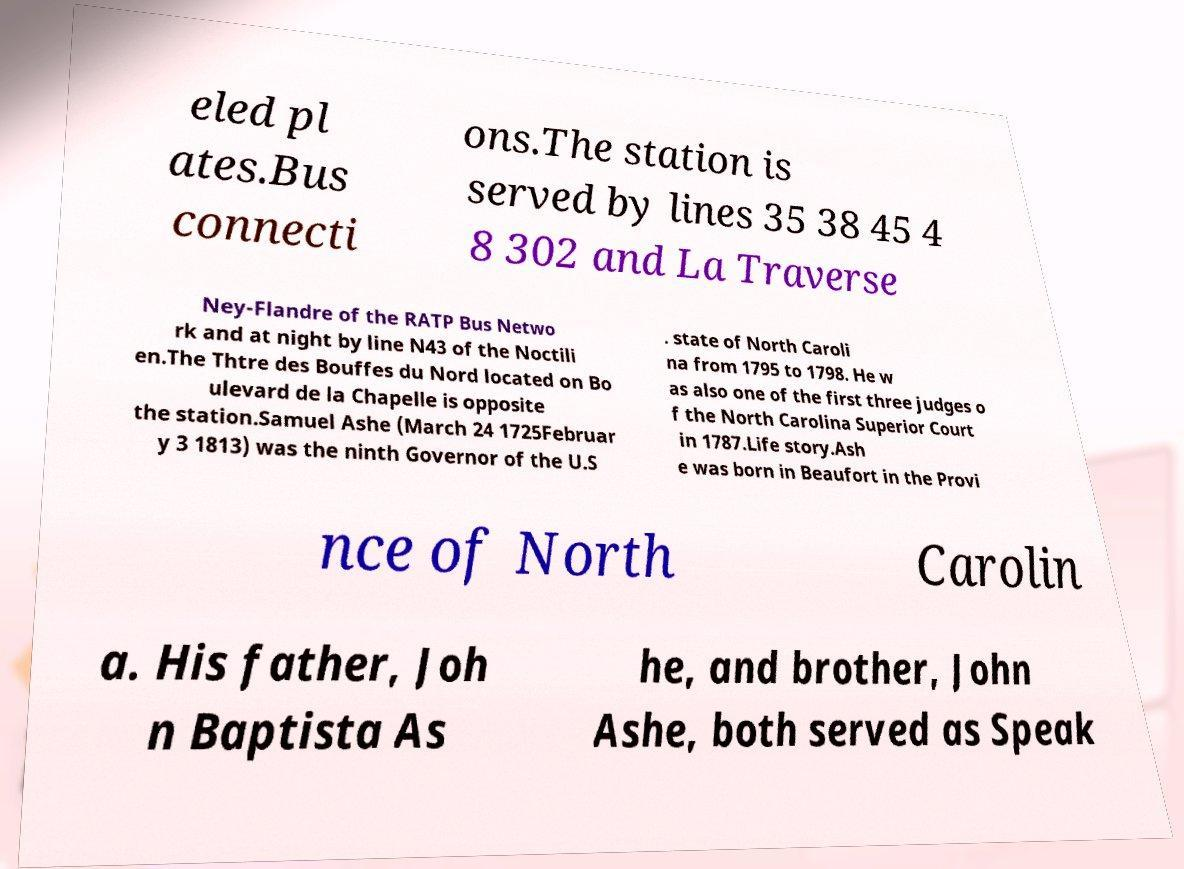Could you extract and type out the text from this image? eled pl ates.Bus connecti ons.The station is served by lines 35 38 45 4 8 302 and La Traverse Ney-Flandre of the RATP Bus Netwo rk and at night by line N43 of the Noctili en.The Thtre des Bouffes du Nord located on Bo ulevard de la Chapelle is opposite the station.Samuel Ashe (March 24 1725Februar y 3 1813) was the ninth Governor of the U.S . state of North Caroli na from 1795 to 1798. He w as also one of the first three judges o f the North Carolina Superior Court in 1787.Life story.Ash e was born in Beaufort in the Provi nce of North Carolin a. His father, Joh n Baptista As he, and brother, John Ashe, both served as Speak 